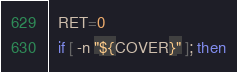Convert code to text. <code><loc_0><loc_0><loc_500><loc_500><_Bash_>  RET=0
  if [ -n "${COVER}" ]; then</code> 